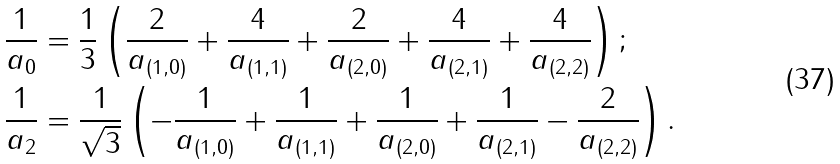Convert formula to latex. <formula><loc_0><loc_0><loc_500><loc_500>\frac { 1 } { a _ { 0 } } & = \frac { 1 } { 3 } \left ( \frac { 2 } { a _ { ( 1 , 0 ) } } + \frac { 4 } { a _ { ( 1 , 1 ) } } + \frac { 2 } { a _ { ( 2 , 0 ) } } + \frac { 4 } { a _ { ( 2 , 1 ) } } + \frac { 4 } { a _ { ( 2 , 2 ) } } \right ) ; \\ \frac { 1 } { a _ { 2 } } & = \frac { 1 } { \sqrt { 3 } } \left ( - \frac { 1 } { a _ { ( 1 , 0 ) } } + \frac { 1 } { a _ { ( 1 , 1 ) } } + \frac { 1 } { a _ { ( 2 , 0 ) } } + \frac { 1 } { a _ { ( 2 , 1 ) } } - \frac { 2 } { a _ { ( 2 , 2 ) } } \right ) .</formula> 